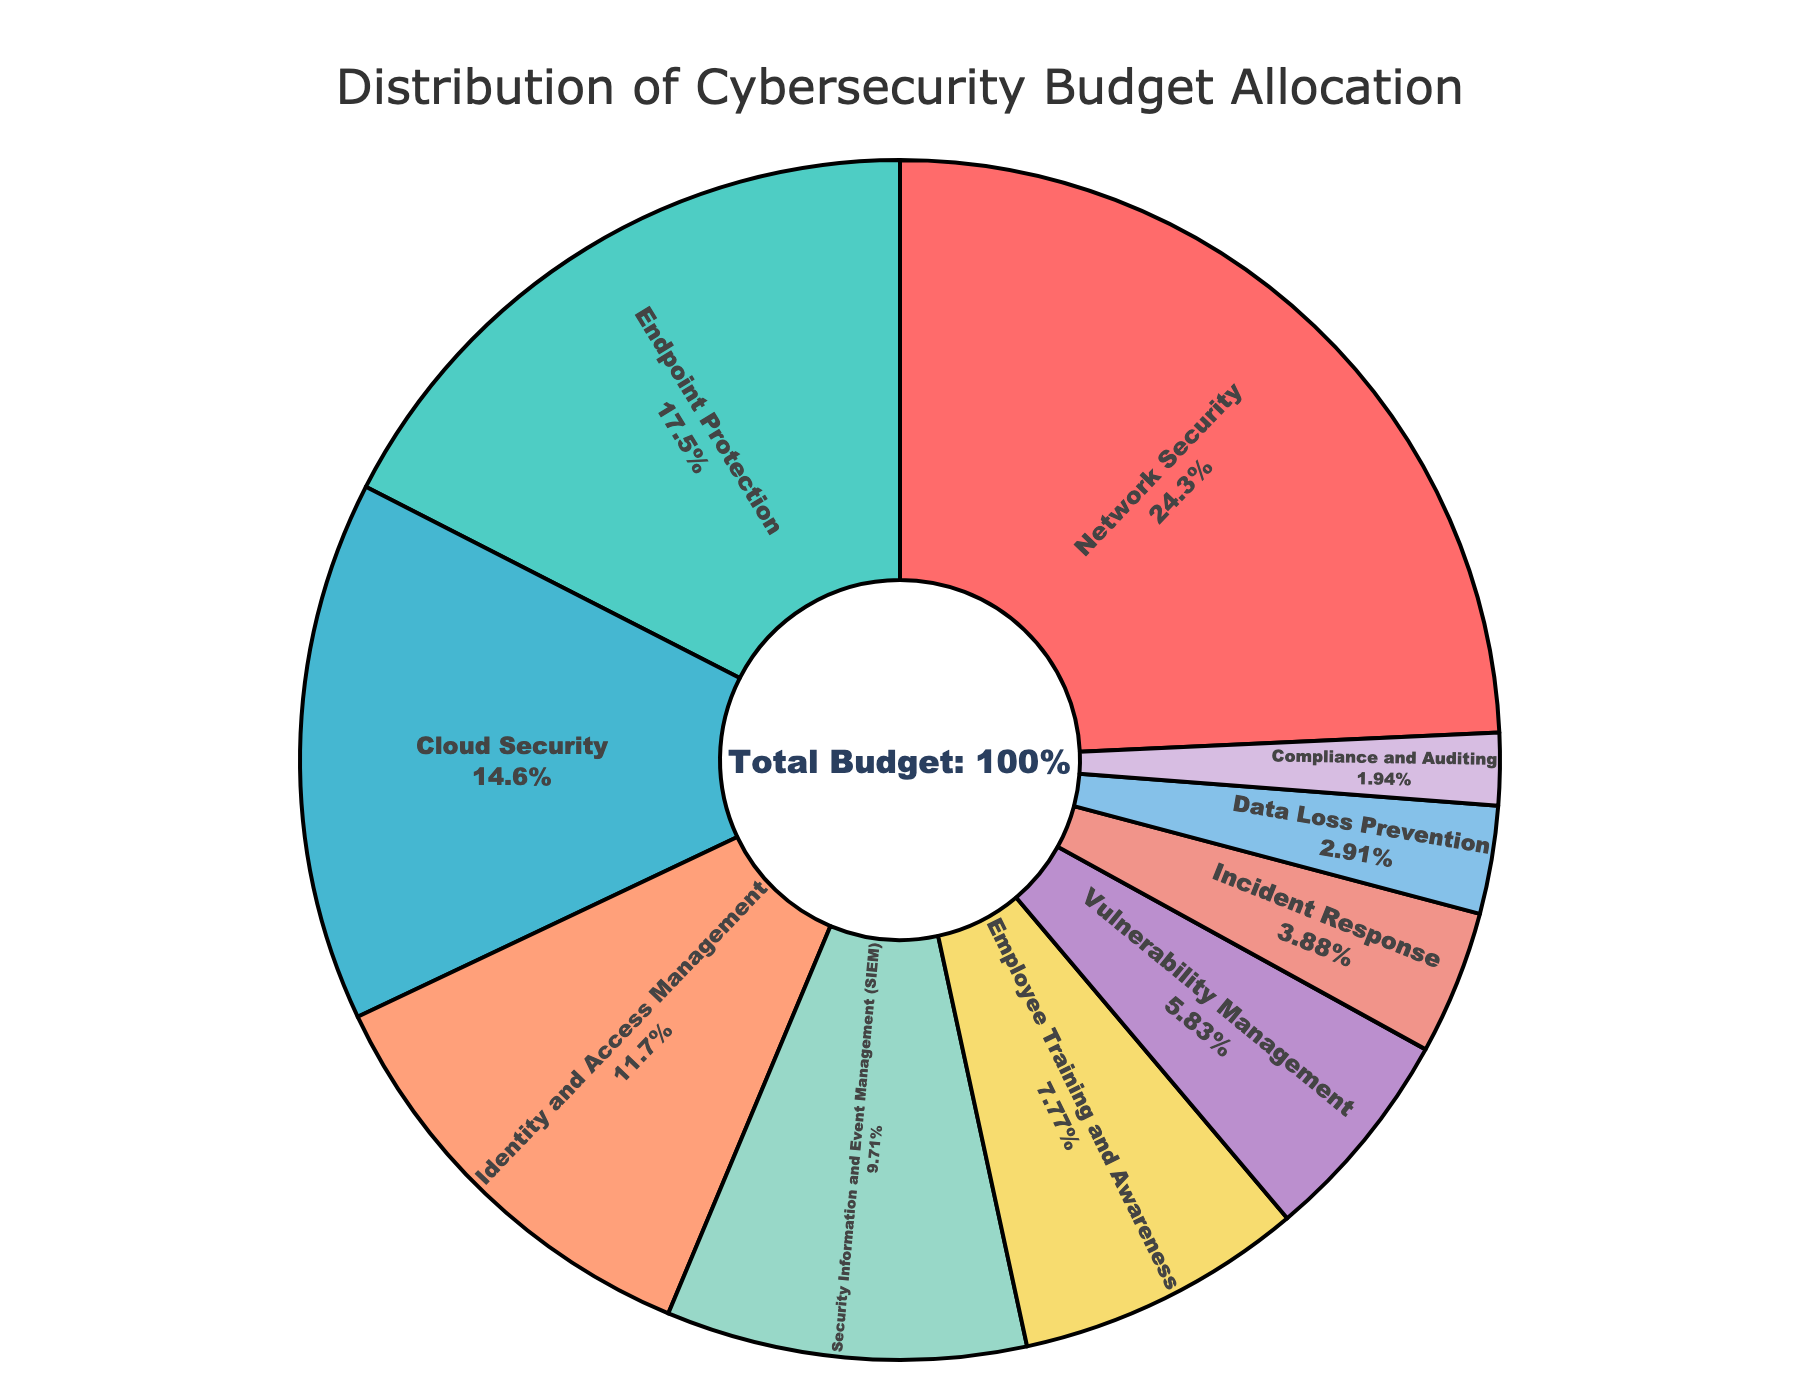Which category has the highest allocation in the cybersecurity budget? The figure shows different security measures with their corresponding budget distribution. The category with the largest percentage slice corresponds to the highest allocation.
Answer: Network Security Which category has the smallest budget allocation? Look for the category with the smallest slice in the pie chart.
Answer: Compliance and Auditing How much more is allocated to Network Security compared to Incident Response? Subtract the percentage allocated to Incident Response from the percentage allocated to Network Security (25% - 4%).
Answer: 21% What is the total percentage allocated to Endpoint Protection and Identity and Access Management? Add the percentages for Endpoint Protection and Identity and Access Management (18% + 12%).
Answer: 30% Which categories have a budget allocation greater than 15%? Identify the slices with percentages greater than 15%.
Answer: Network Security, Endpoint Protection, Cloud Security How much less is allocated to Data Loss Prevention compared to Employee Training and Awareness? Subtract the percentage allocated to Data Loss Prevention from Employee Training and Awareness (8% - 3%).
Answer: 5% What is the cumulative budget allocation for Cloud Security, Vulnerability Management, and Incident Response? Add the percentages for Cloud Security, Vulnerability Management, and Incident Response (15% + 6% + 4%).
Answer: 25% Is the percentage allocated to SIEM higher or lower than the percentage allocated to Identity and Access Management? Compare the percentage of SIEM to Identity and Access Management (SIEM: 10%, IAM: 12%).
Answer: Lower What color represents Cloud Security? Identify the color associated with the Cloud Security slice in the pie chart.
Answer: Light blue (assumed from common color schemes) How much is the combined budget allocation for Network Security and Employee Training and Awareness? Add the percentages for Network Security and Employee Training and Awareness (25% + 8%).
Answer: 33% 